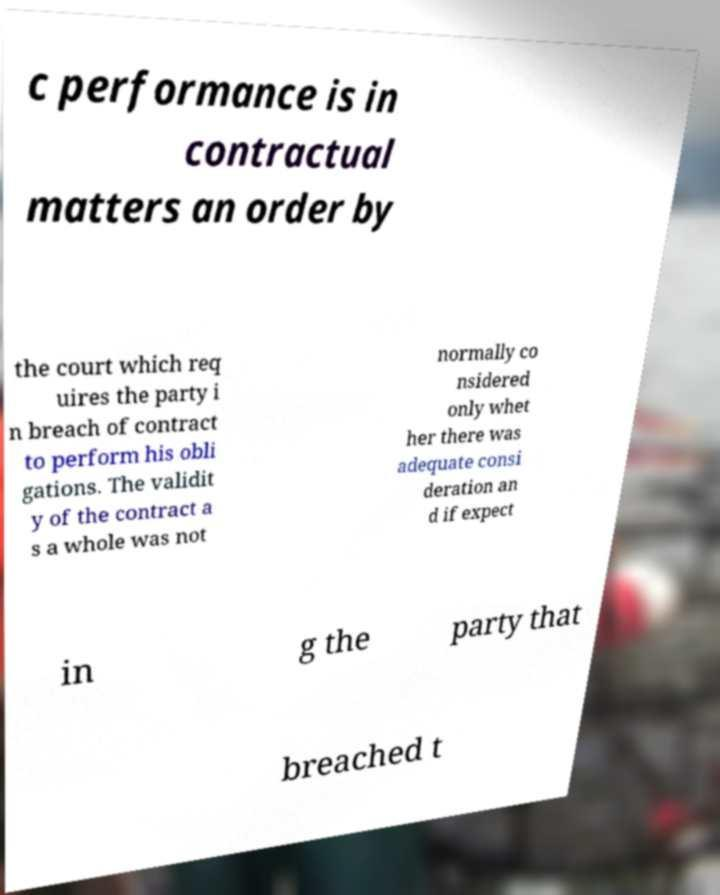Could you assist in decoding the text presented in this image and type it out clearly? c performance is in contractual matters an order by the court which req uires the party i n breach of contract to perform his obli gations. The validit y of the contract a s a whole was not normally co nsidered only whet her there was adequate consi deration an d if expect in g the party that breached t 